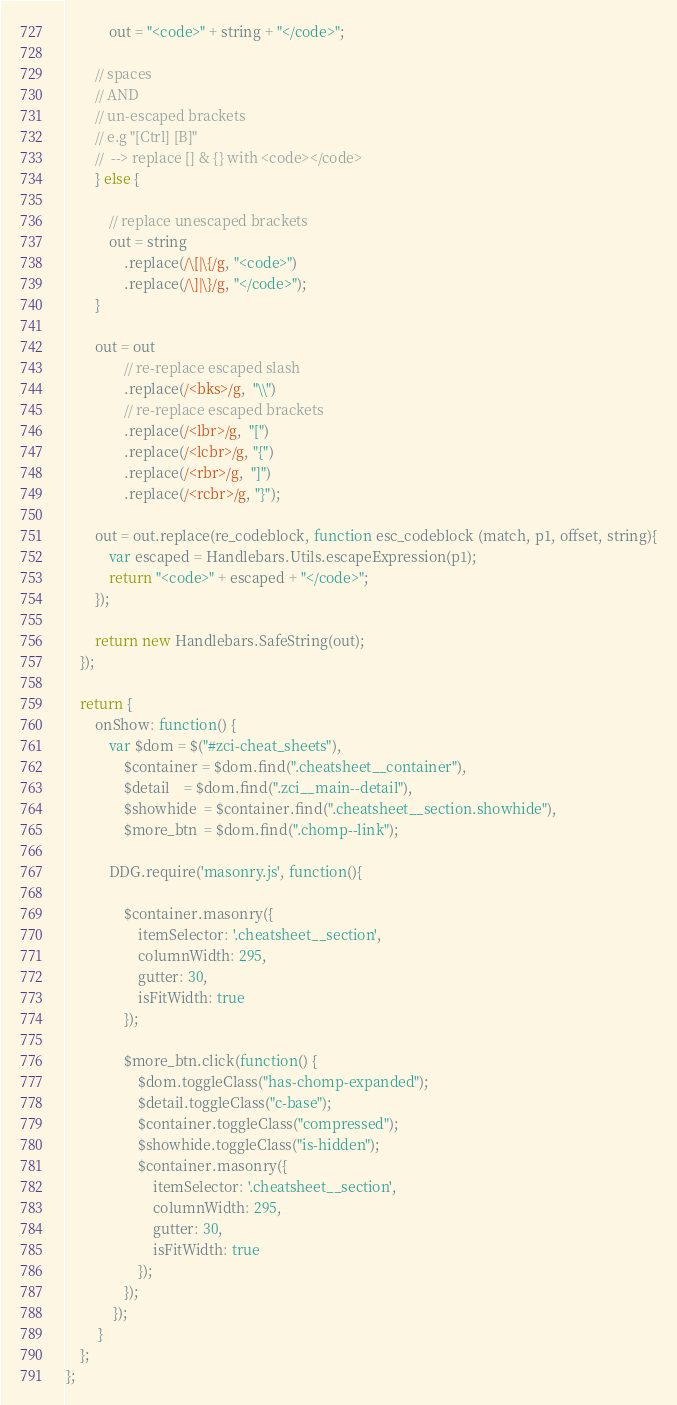Convert code to text. <code><loc_0><loc_0><loc_500><loc_500><_JavaScript_>            out = "<code>" + string + "</code>";

        // spaces
        // AND
        // un-escaped brackets
        // e.g "[Ctrl] [B]"
        //  --> replace [] & {} with <code></code>
        } else {

            // replace unescaped brackets
            out = string
                .replace(/\[|\{/g, "<code>")
                .replace(/\]|\}/g, "</code>");
        }

        out = out
                // re-replace escaped slash
                .replace(/<bks>/g,  "\\")
                // re-replace escaped brackets
                .replace(/<lbr>/g,  "[")
                .replace(/<lcbr>/g, "{")
                .replace(/<rbr>/g,  "]")
                .replace(/<rcbr>/g, "}");

        out = out.replace(re_codeblock, function esc_codeblock (match, p1, offset, string){
            var escaped = Handlebars.Utils.escapeExpression(p1);
            return "<code>" + escaped + "</code>";
        });

        return new Handlebars.SafeString(out);
    });

    return {
        onShow: function() {
            var $dom = $("#zci-cheat_sheets"),
                $container = $dom.find(".cheatsheet__container"),
                $detail    = $dom.find(".zci__main--detail"),
                $showhide  = $container.find(".cheatsheet__section.showhide"),
                $more_btn  = $dom.find(".chomp--link");

            DDG.require('masonry.js', function(){

                $container.masonry({
                    itemSelector: '.cheatsheet__section',
                    columnWidth: 295,
                    gutter: 30,
                    isFitWidth: true
                });

                $more_btn.click(function() {
                    $dom.toggleClass("has-chomp-expanded");
                    $detail.toggleClass("c-base");
                    $container.toggleClass("compressed");
                    $showhide.toggleClass("is-hidden");
                    $container.masonry({
                        itemSelector: '.cheatsheet__section',
                        columnWidth: 295,
                        gutter: 30,
                        isFitWidth: true
                    });
                });
             });
         }
    };
};
</code> 